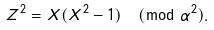<formula> <loc_0><loc_0><loc_500><loc_500>Z ^ { 2 } = X ( X ^ { 2 } - 1 ) \pmod { \alpha ^ { 2 } } .</formula> 